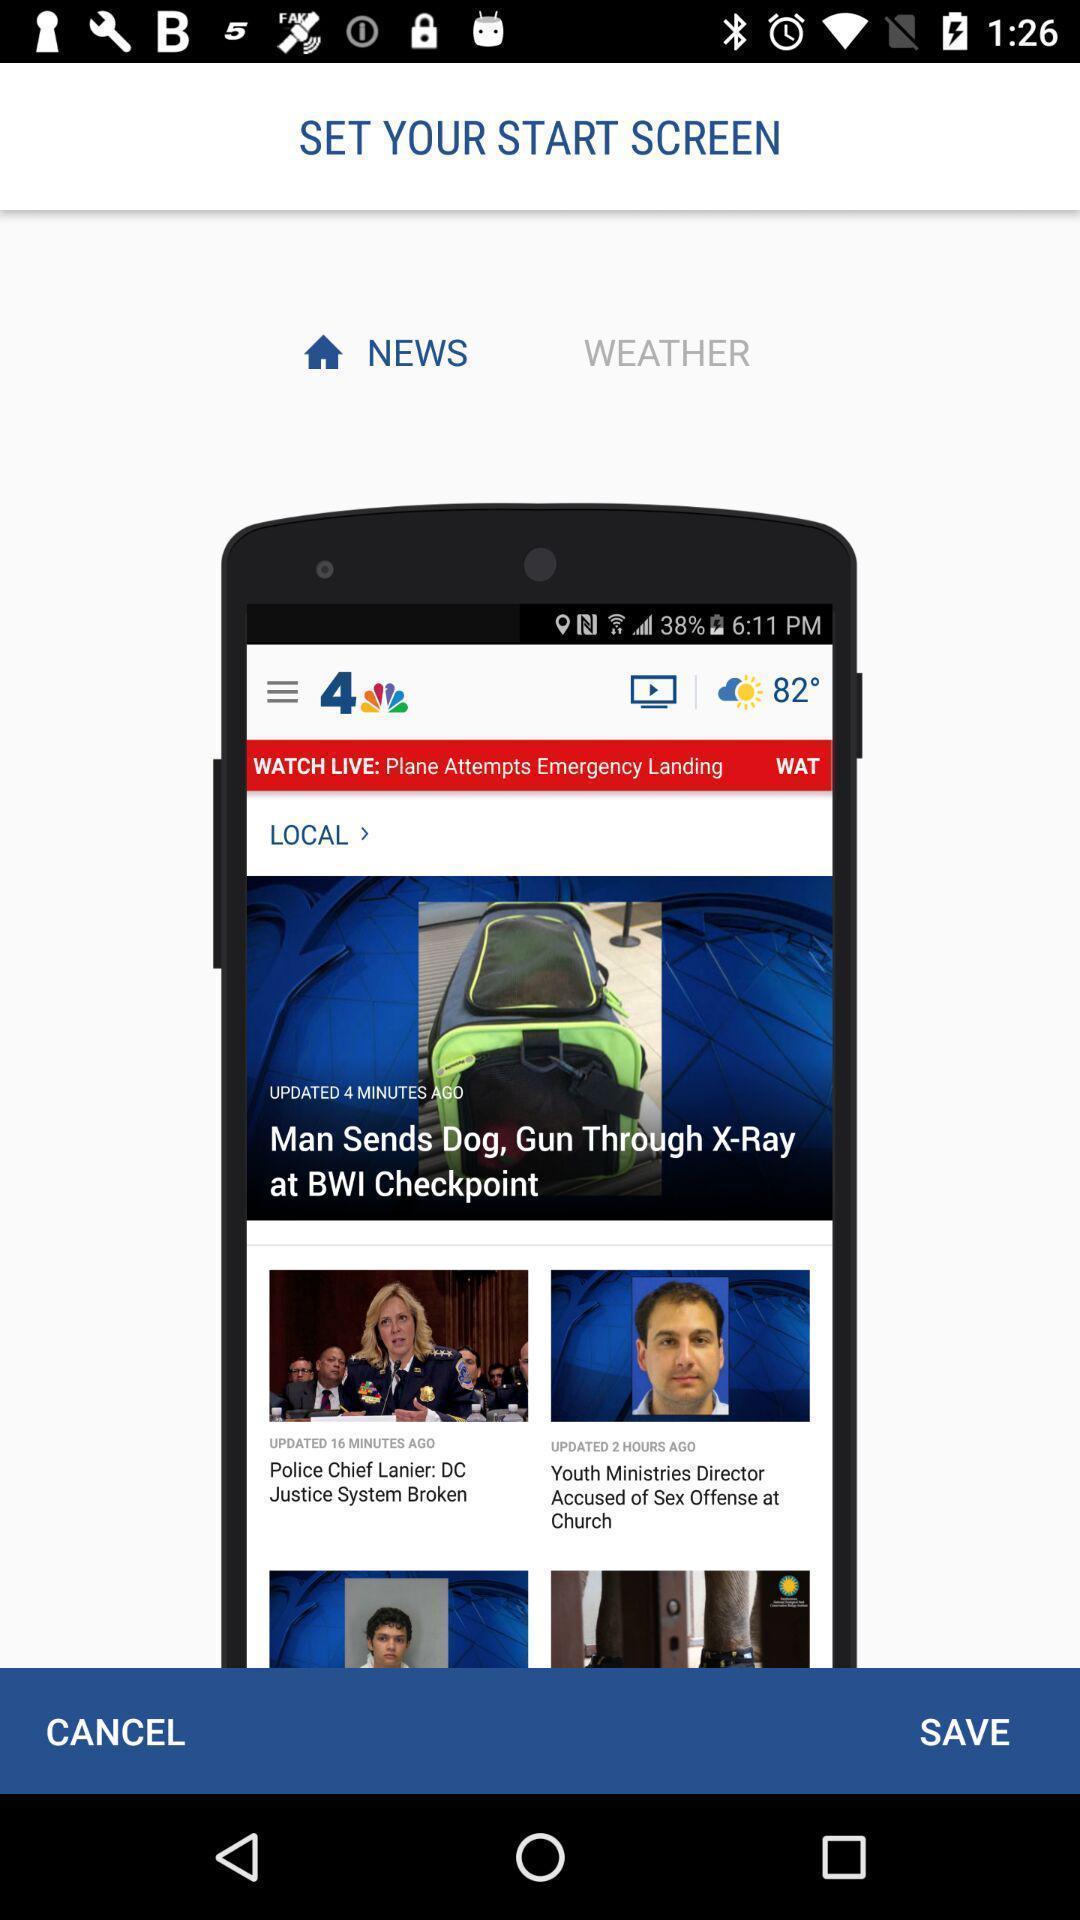Provide a detailed account of this screenshot. Welcome page of a news app. 